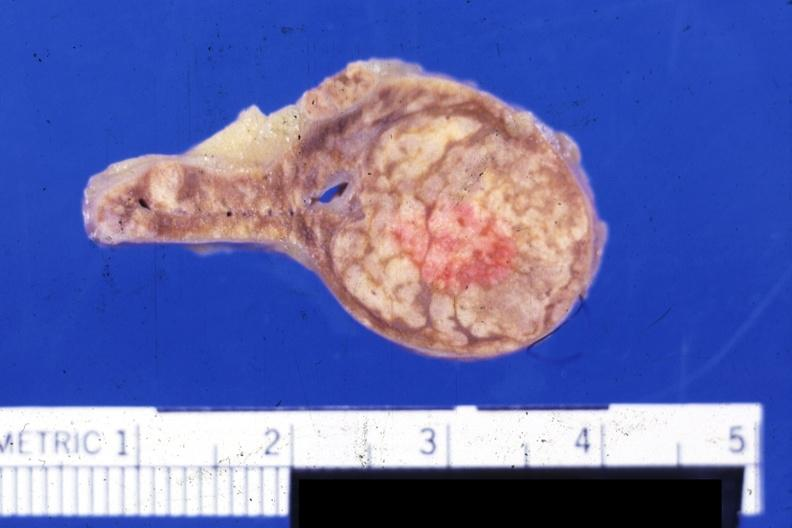what is present?
Answer the question using a single word or phrase. Adrenal 